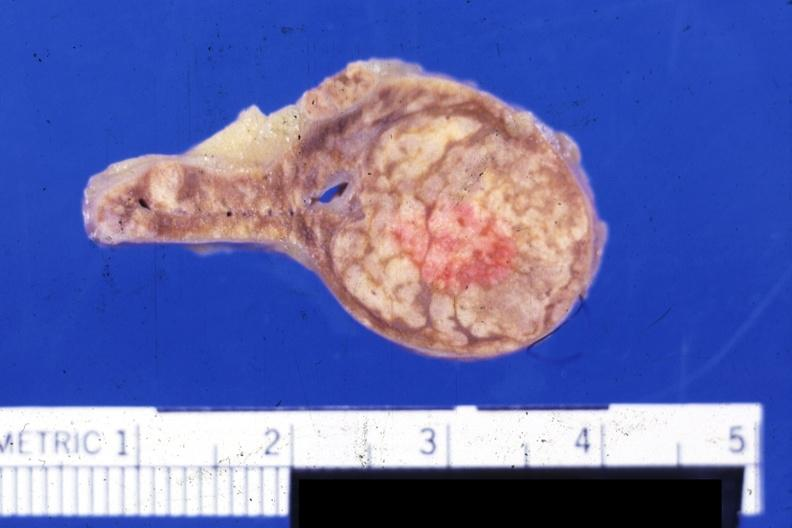what is present?
Answer the question using a single word or phrase. Adrenal 